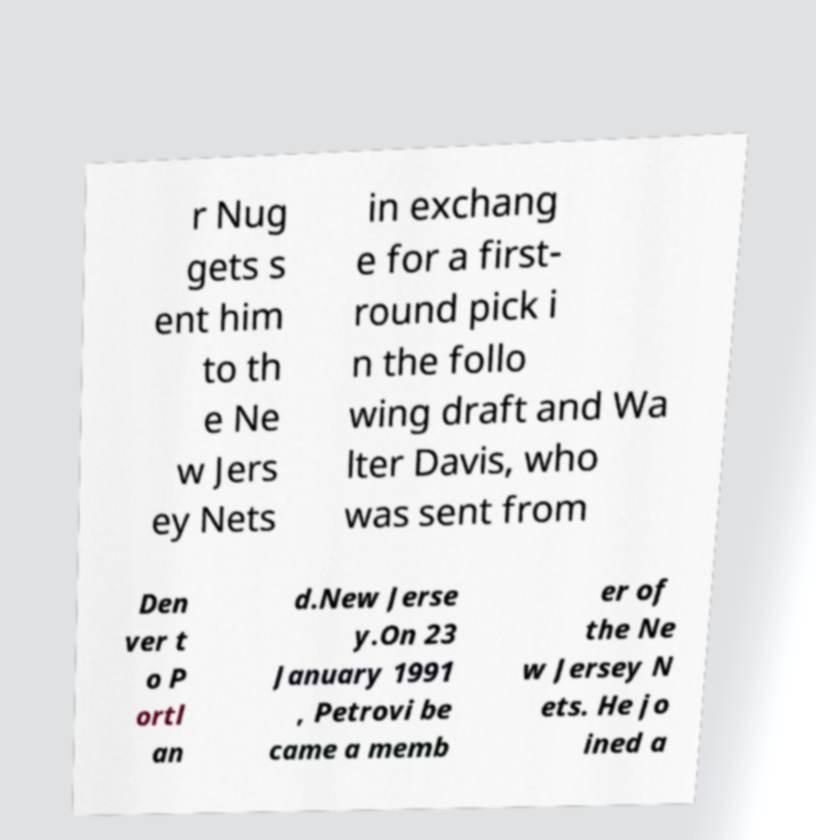For documentation purposes, I need the text within this image transcribed. Could you provide that? r Nug gets s ent him to th e Ne w Jers ey Nets in exchang e for a first- round pick i n the follo wing draft and Wa lter Davis, who was sent from Den ver t o P ortl an d.New Jerse y.On 23 January 1991 , Petrovi be came a memb er of the Ne w Jersey N ets. He jo ined a 